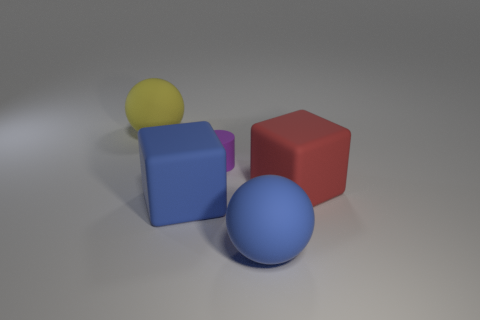Add 3 big gray rubber blocks. How many objects exist? 8 Subtract all red cubes. How many cubes are left? 1 Subtract all blocks. How many objects are left? 3 Subtract all tiny red blocks. Subtract all small matte cylinders. How many objects are left? 4 Add 4 yellow rubber objects. How many yellow rubber objects are left? 5 Add 2 large matte things. How many large matte things exist? 6 Subtract 1 purple cylinders. How many objects are left? 4 Subtract 1 cylinders. How many cylinders are left? 0 Subtract all gray blocks. Subtract all blue cylinders. How many blocks are left? 2 